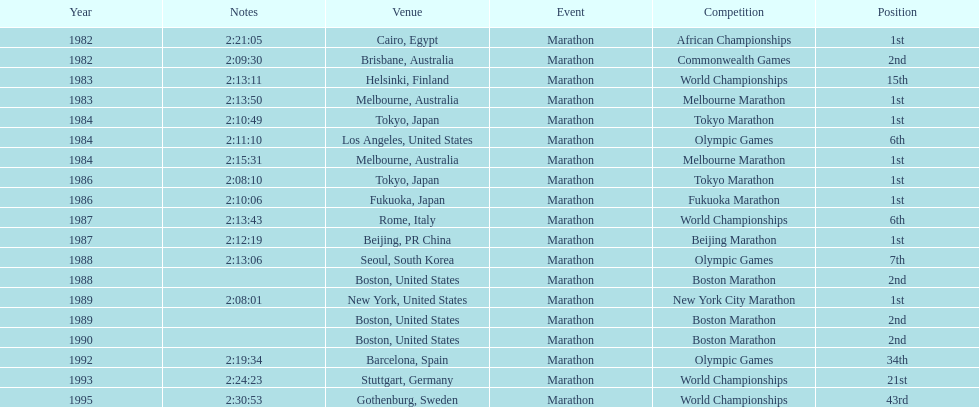What are the total number of times the position of 1st place was earned? 8. 